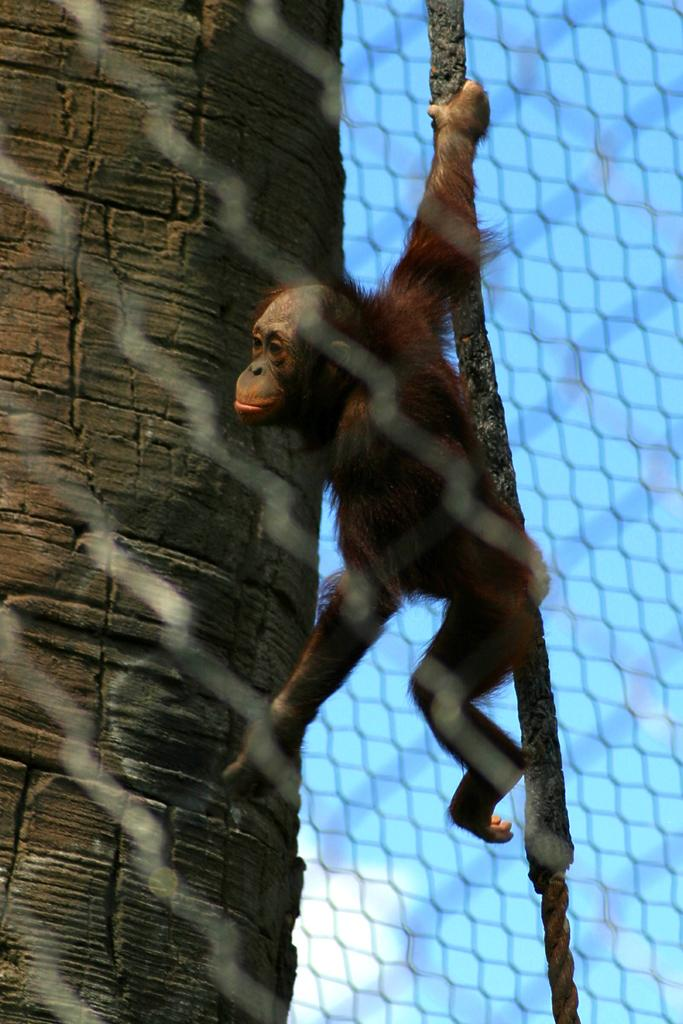What type of structure can be seen in the image? There is a fence in the image. What other subject is present in the image? There is an animal in the image. What is the value of the shop in the image? There is no shop present in the image, so it is not possible to determine its value. 